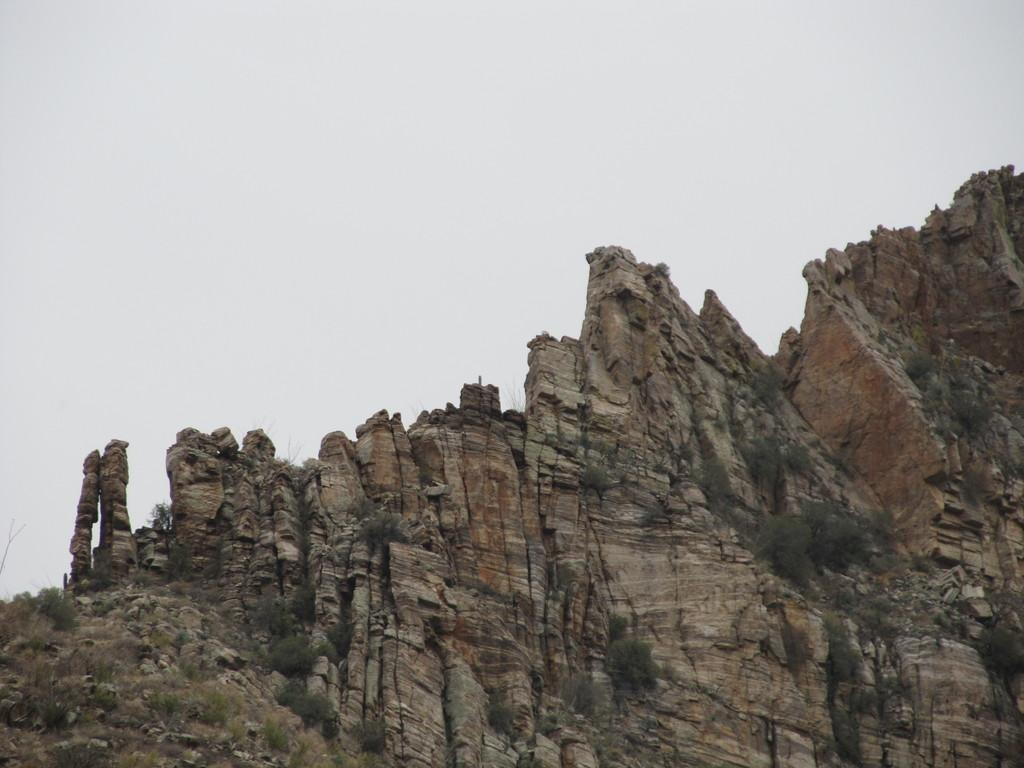What type of landform is present in the image? There is a hill in the image. What other natural elements can be seen in the image? There are rocks, grass, and plants visible in the image. What is visible at the top of the image? The sky is visible at the top of the image. What type of sock is hanging on the tree in the image? There is no sock present in the image; it features a hill, rocks, grass, plants, and the sky. 